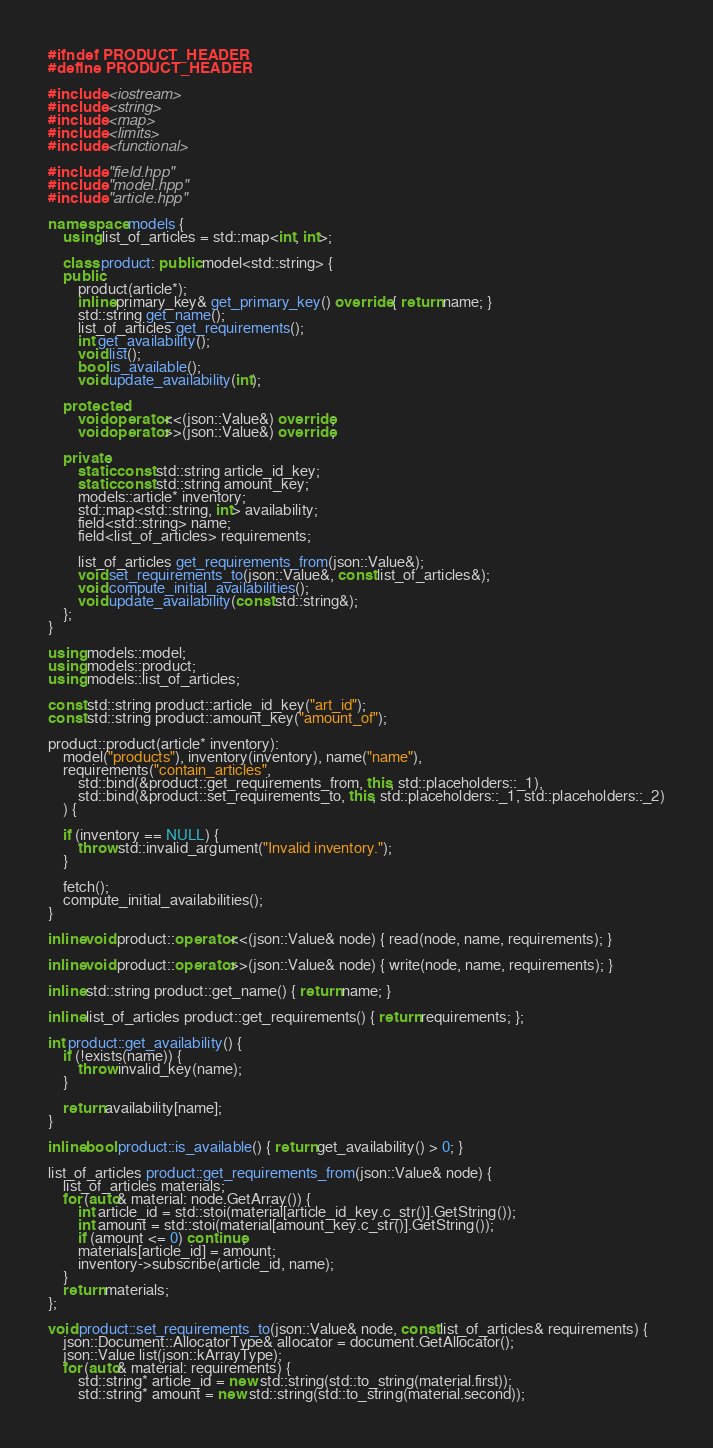Convert code to text. <code><loc_0><loc_0><loc_500><loc_500><_C++_>#ifndef PRODUCT_HEADER
#define PRODUCT_HEADER

#include <iostream>
#include <string>
#include <map>
#include <limits>
#include <functional>

#include "field.hpp"
#include "model.hpp"
#include "article.hpp"

namespace models {
	using list_of_articles = std::map<int, int>;

	class product: public model<std::string> {
	public:
		product(article*);
		inline primary_key& get_primary_key() override { return name; }
		std::string get_name();
		list_of_articles get_requirements();
		int get_availability();
		void list();
		bool is_available();
		void update_availability(int);

	protected:
		void operator<<(json::Value&) override;
		void operator>>(json::Value&) override;

	private:
		static const std::string article_id_key;
		static const std::string amount_key;
		models::article* inventory;
		std::map<std::string, int> availability;
		field<std::string> name;
		field<list_of_articles> requirements;

		list_of_articles get_requirements_from(json::Value&);
		void set_requirements_to(json::Value&, const list_of_articles&);
		void compute_initial_availabilities();
		void update_availability(const std::string&);
	};
}

using models::model;
using models::product;
using models::list_of_articles;

const std::string product::article_id_key("art_id");
const std::string product::amount_key("amount_of");

product::product(article* inventory):
	model("products"), inventory(inventory), name("name"),
	requirements("contain_articles",
		std::bind(&product::get_requirements_from, this, std::placeholders::_1),
		std::bind(&product::set_requirements_to, this, std::placeholders::_1, std::placeholders::_2)
	) {

	if (inventory == NULL) {
		throw std::invalid_argument("Invalid inventory.");
	}

	fetch();
	compute_initial_availabilities();
}

inline void product::operator<<(json::Value& node) { read(node, name, requirements); }

inline void product::operator>>(json::Value& node) { write(node, name, requirements); }

inline std::string product::get_name() { return name; }

inline list_of_articles product::get_requirements() { return requirements; };

int product::get_availability() {
	if (!exists(name)) {
		throw invalid_key(name);
	}

	return availability[name];
}

inline bool product::is_available() { return get_availability() > 0; }

list_of_articles product::get_requirements_from(json::Value& node) {
	list_of_articles materials;
	for (auto& material: node.GetArray()) {
		int article_id = std::stoi(material[article_id_key.c_str()].GetString());
		int amount = std::stoi(material[amount_key.c_str()].GetString());
		if (amount <= 0) continue;
		materials[article_id] = amount;
		inventory->subscribe(article_id, name);
	}
	return materials;
};

void product::set_requirements_to(json::Value& node, const list_of_articles& requirements) {
	json::Document::AllocatorType& allocator = document.GetAllocator();
	json::Value list(json::kArrayType);
	for (auto& material: requirements) {
		std::string* article_id = new std::string(std::to_string(material.first));
		std::string* amount = new std::string(std::to_string(material.second));</code> 